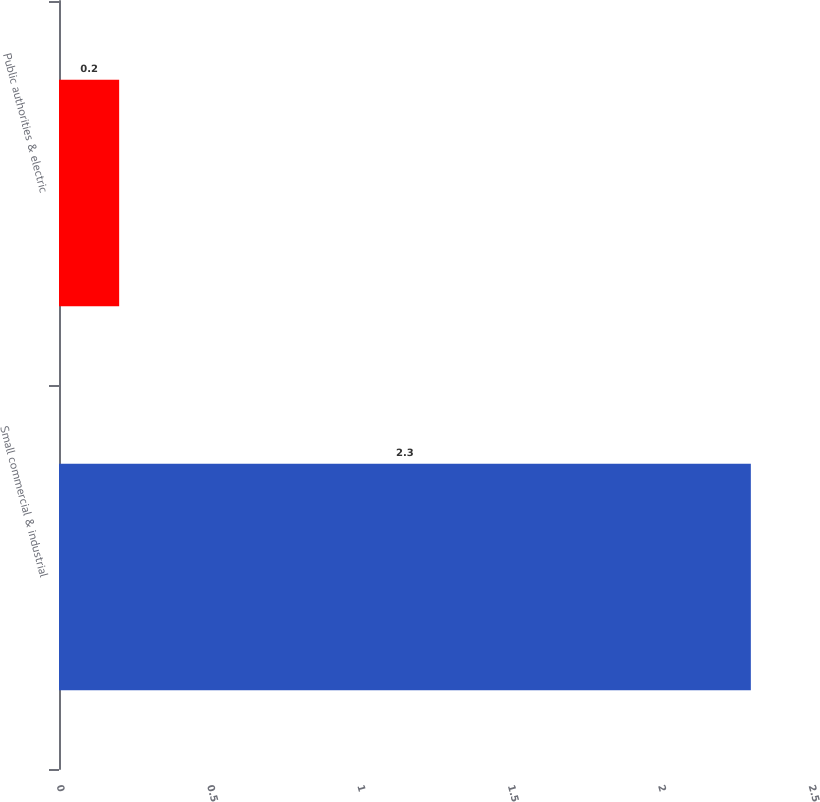<chart> <loc_0><loc_0><loc_500><loc_500><bar_chart><fcel>Small commercial & industrial<fcel>Public authorities & electric<nl><fcel>2.3<fcel>0.2<nl></chart> 